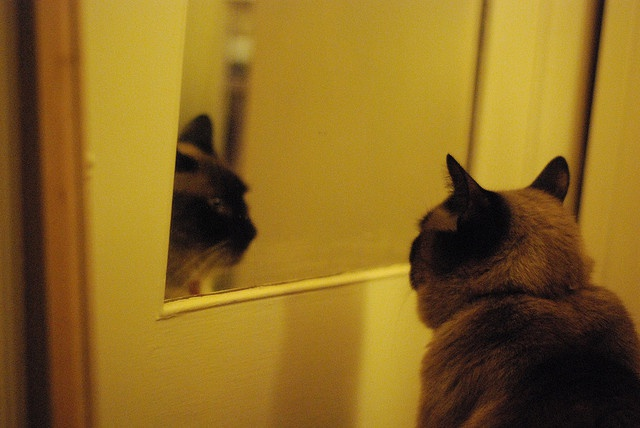Describe the objects in this image and their specific colors. I can see a cat in maroon, black, and olive tones in this image. 